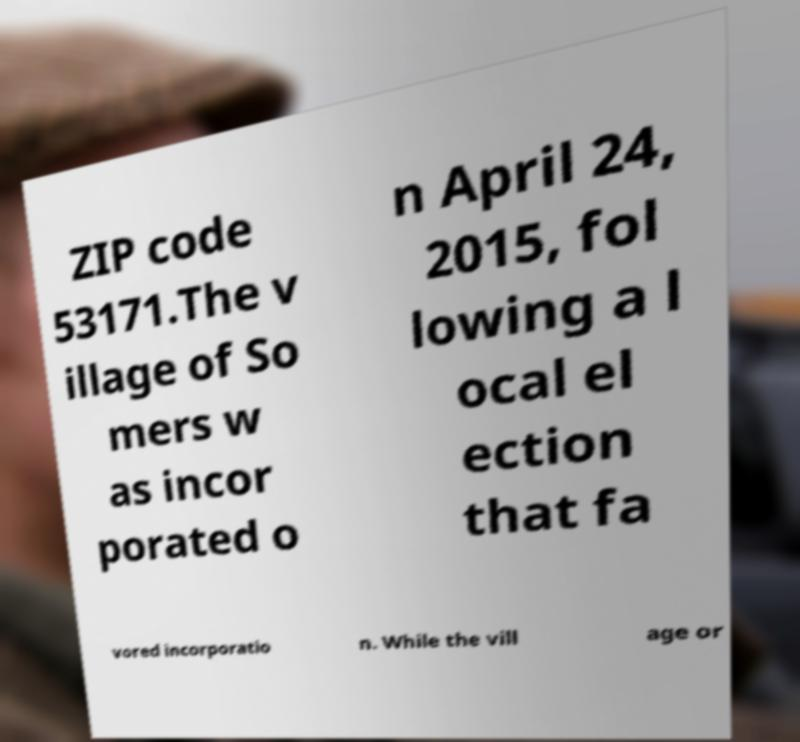Can you read and provide the text displayed in the image?This photo seems to have some interesting text. Can you extract and type it out for me? ZIP code 53171.The v illage of So mers w as incor porated o n April 24, 2015, fol lowing a l ocal el ection that fa vored incorporatio n. While the vill age or 